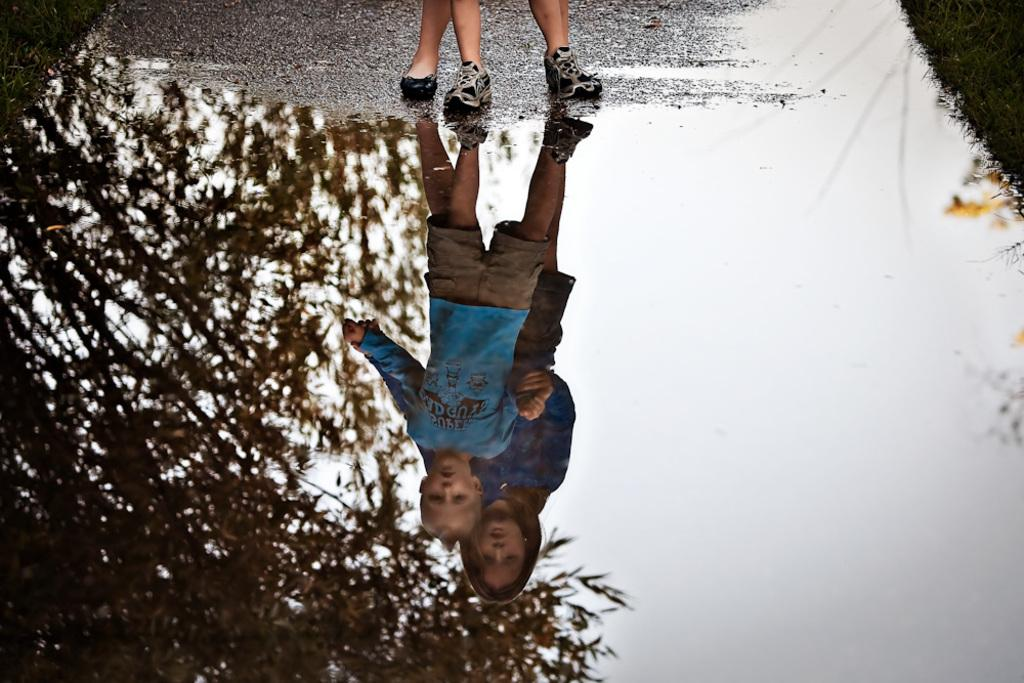What is the primary element in the image? There is water in the image. What type of vegetation can be seen in the image? There is grass in the image. What does the water in the image reflect? The water reflects people, trees, and the sky. Can you describe the people visible in the image? There are logs of people visible at the top of the image. What type of wool is being used by the farmer in the image? There is no farmer or wool present in the image. What is the afterthought of the people in the image? The provided facts do not mention any afterthoughts of the people in the image. 